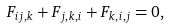Convert formula to latex. <formula><loc_0><loc_0><loc_500><loc_500>F _ { i j , k } + F _ { j , k , i } + F _ { k , i , j } = 0 ,</formula> 